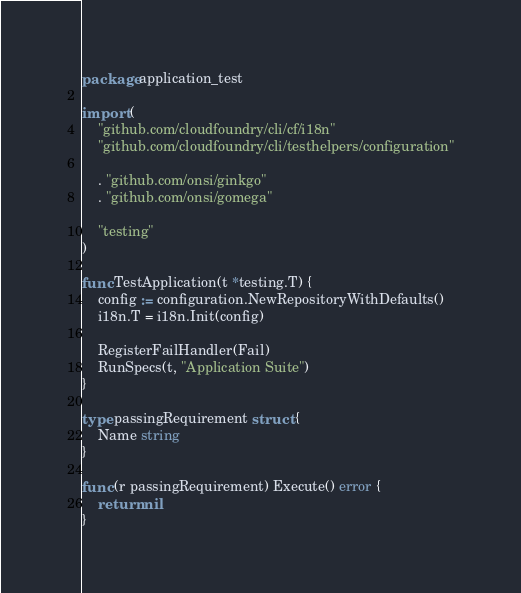Convert code to text. <code><loc_0><loc_0><loc_500><loc_500><_Go_>package application_test

import (
	"github.com/cloudfoundry/cli/cf/i18n"
	"github.com/cloudfoundry/cli/testhelpers/configuration"

	. "github.com/onsi/ginkgo"
	. "github.com/onsi/gomega"

	"testing"
)

func TestApplication(t *testing.T) {
	config := configuration.NewRepositoryWithDefaults()
	i18n.T = i18n.Init(config)

	RegisterFailHandler(Fail)
	RunSpecs(t, "Application Suite")
}

type passingRequirement struct {
	Name string
}

func (r passingRequirement) Execute() error {
	return nil
}
</code> 